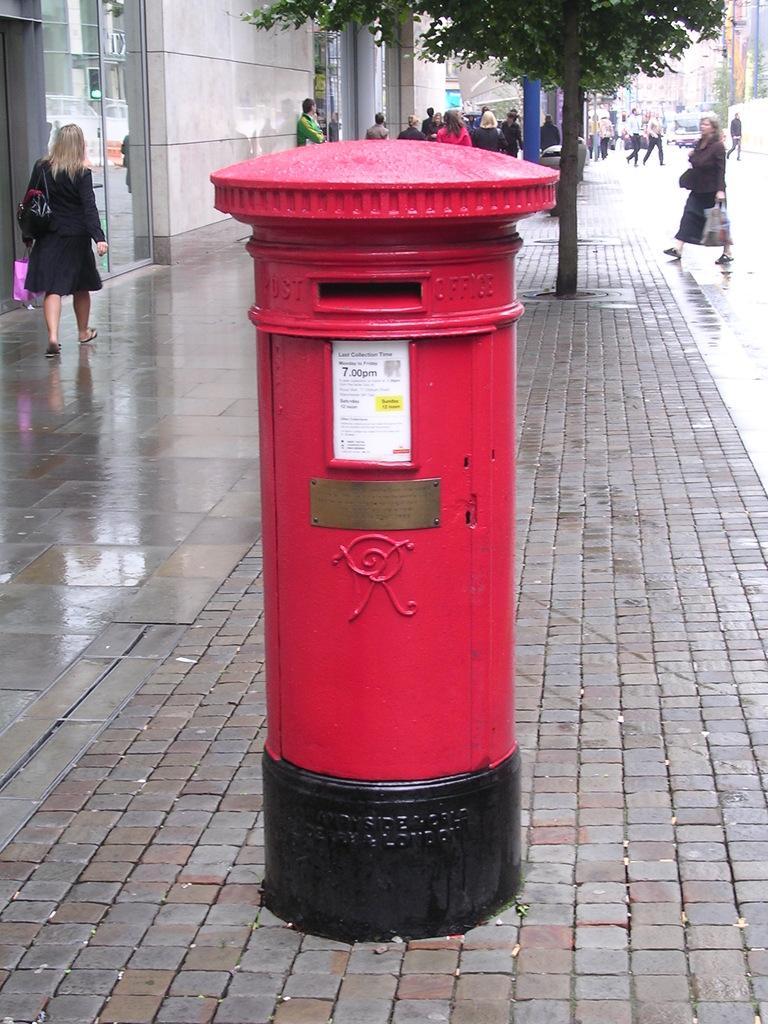Please provide a concise description of this image. In this image there is a post box on the road, behind that there is a plant and also people walking on the road, beside that there is a building. 